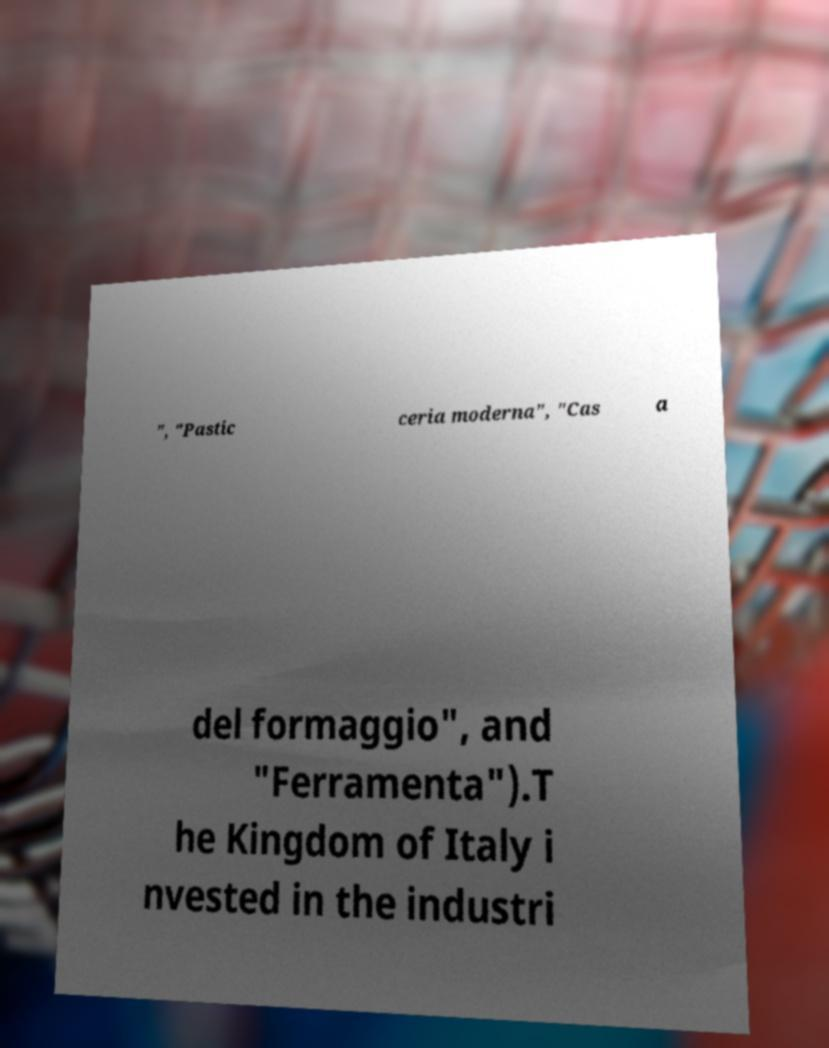Please read and relay the text visible in this image. What does it say? ", "Pastic ceria moderna", "Cas a del formaggio", and "Ferramenta").T he Kingdom of Italy i nvested in the industri 